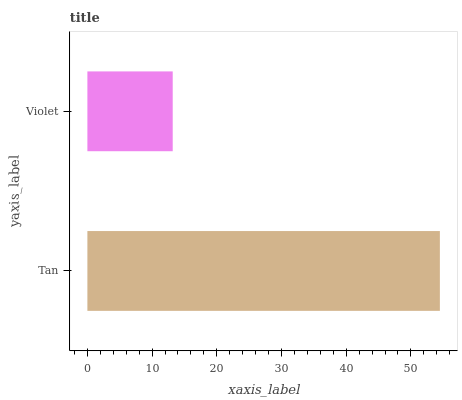Is Violet the minimum?
Answer yes or no. Yes. Is Tan the maximum?
Answer yes or no. Yes. Is Violet the maximum?
Answer yes or no. No. Is Tan greater than Violet?
Answer yes or no. Yes. Is Violet less than Tan?
Answer yes or no. Yes. Is Violet greater than Tan?
Answer yes or no. No. Is Tan less than Violet?
Answer yes or no. No. Is Tan the high median?
Answer yes or no. Yes. Is Violet the low median?
Answer yes or no. Yes. Is Violet the high median?
Answer yes or no. No. Is Tan the low median?
Answer yes or no. No. 